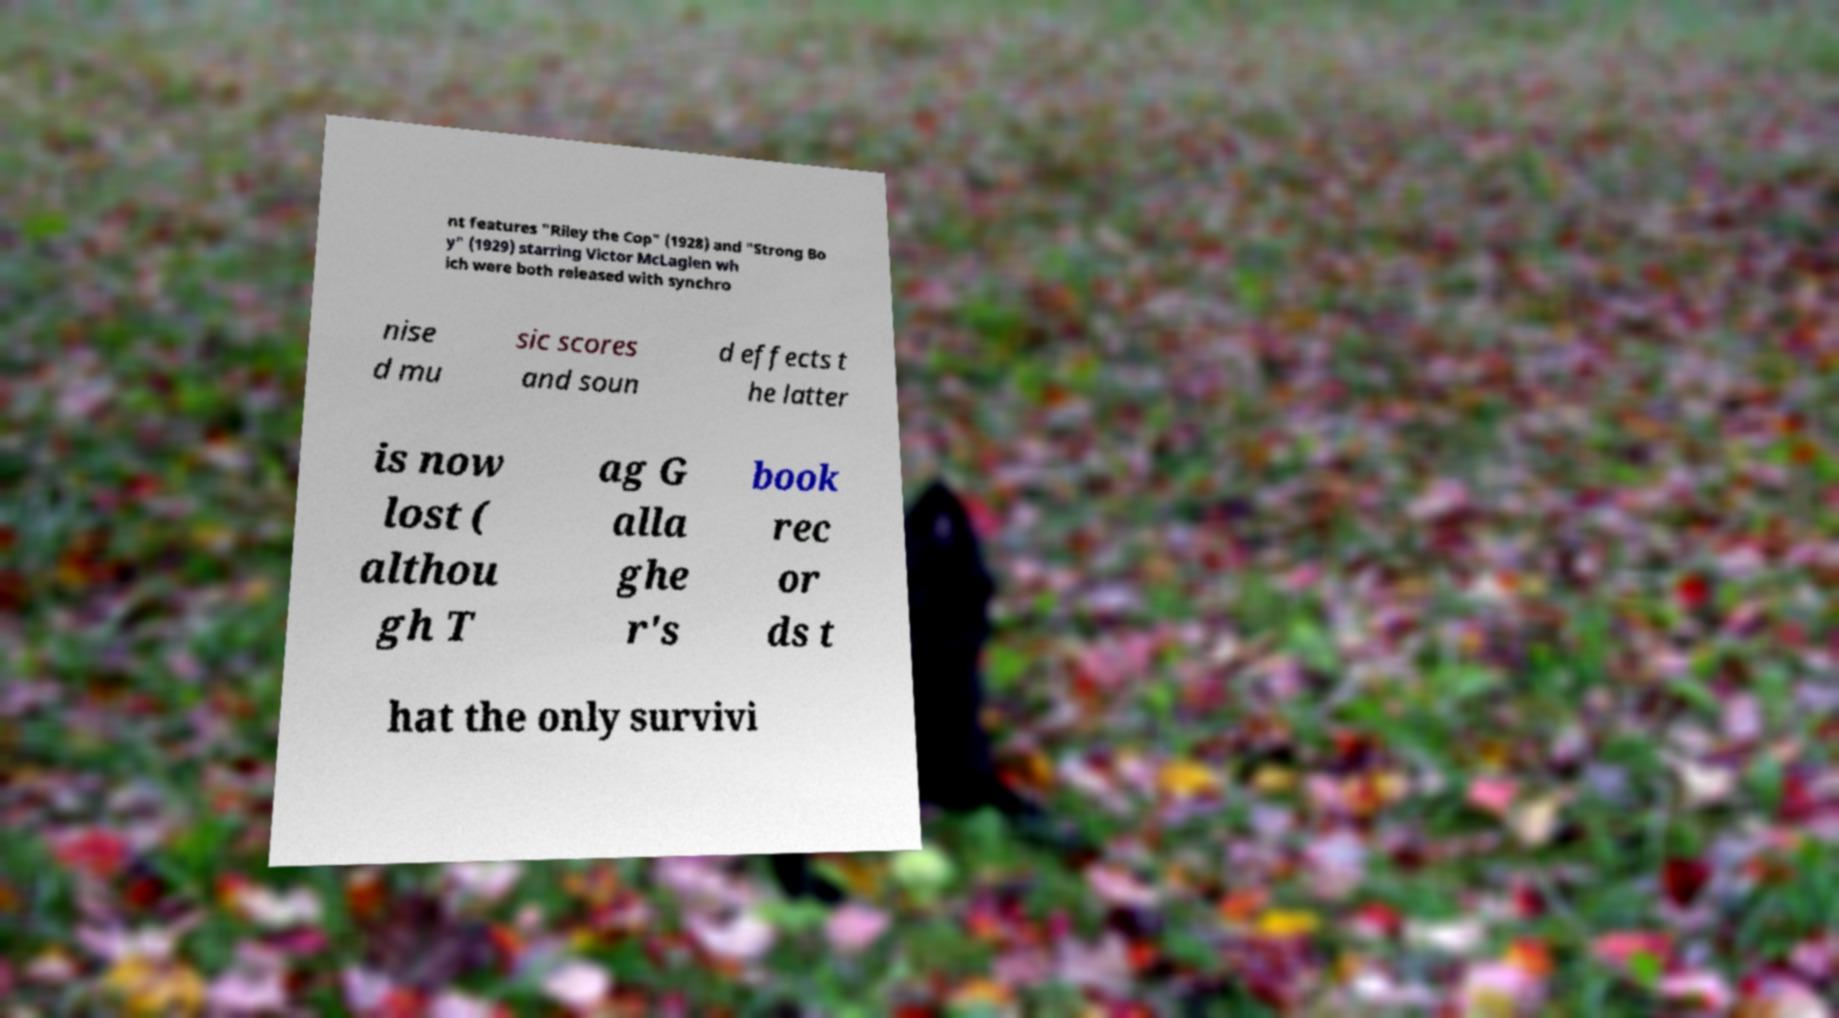What messages or text are displayed in this image? I need them in a readable, typed format. nt features "Riley the Cop" (1928) and "Strong Bo y" (1929) starring Victor McLaglen wh ich were both released with synchro nise d mu sic scores and soun d effects t he latter is now lost ( althou gh T ag G alla ghe r's book rec or ds t hat the only survivi 